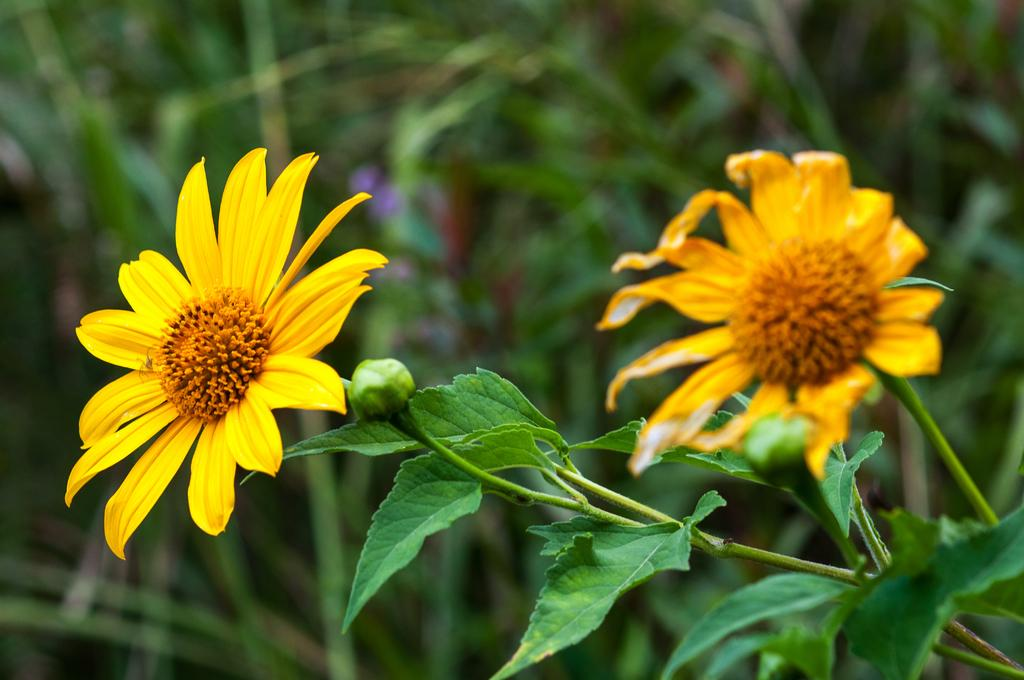What type of plant life is visible in the image? There are flowers, buds, leaves, and stems in the image. Can you describe the different parts of the plants in the image? Yes, there are flowers, buds, leaves, and stems visible in the image. What is the background of the image like? The background of the image is blurry. What month is it in the image? The image does not provide any information about the month or time of year. Can you tell me how many lizards are present in the image? There are no lizards visible in the image; it features plant life. 